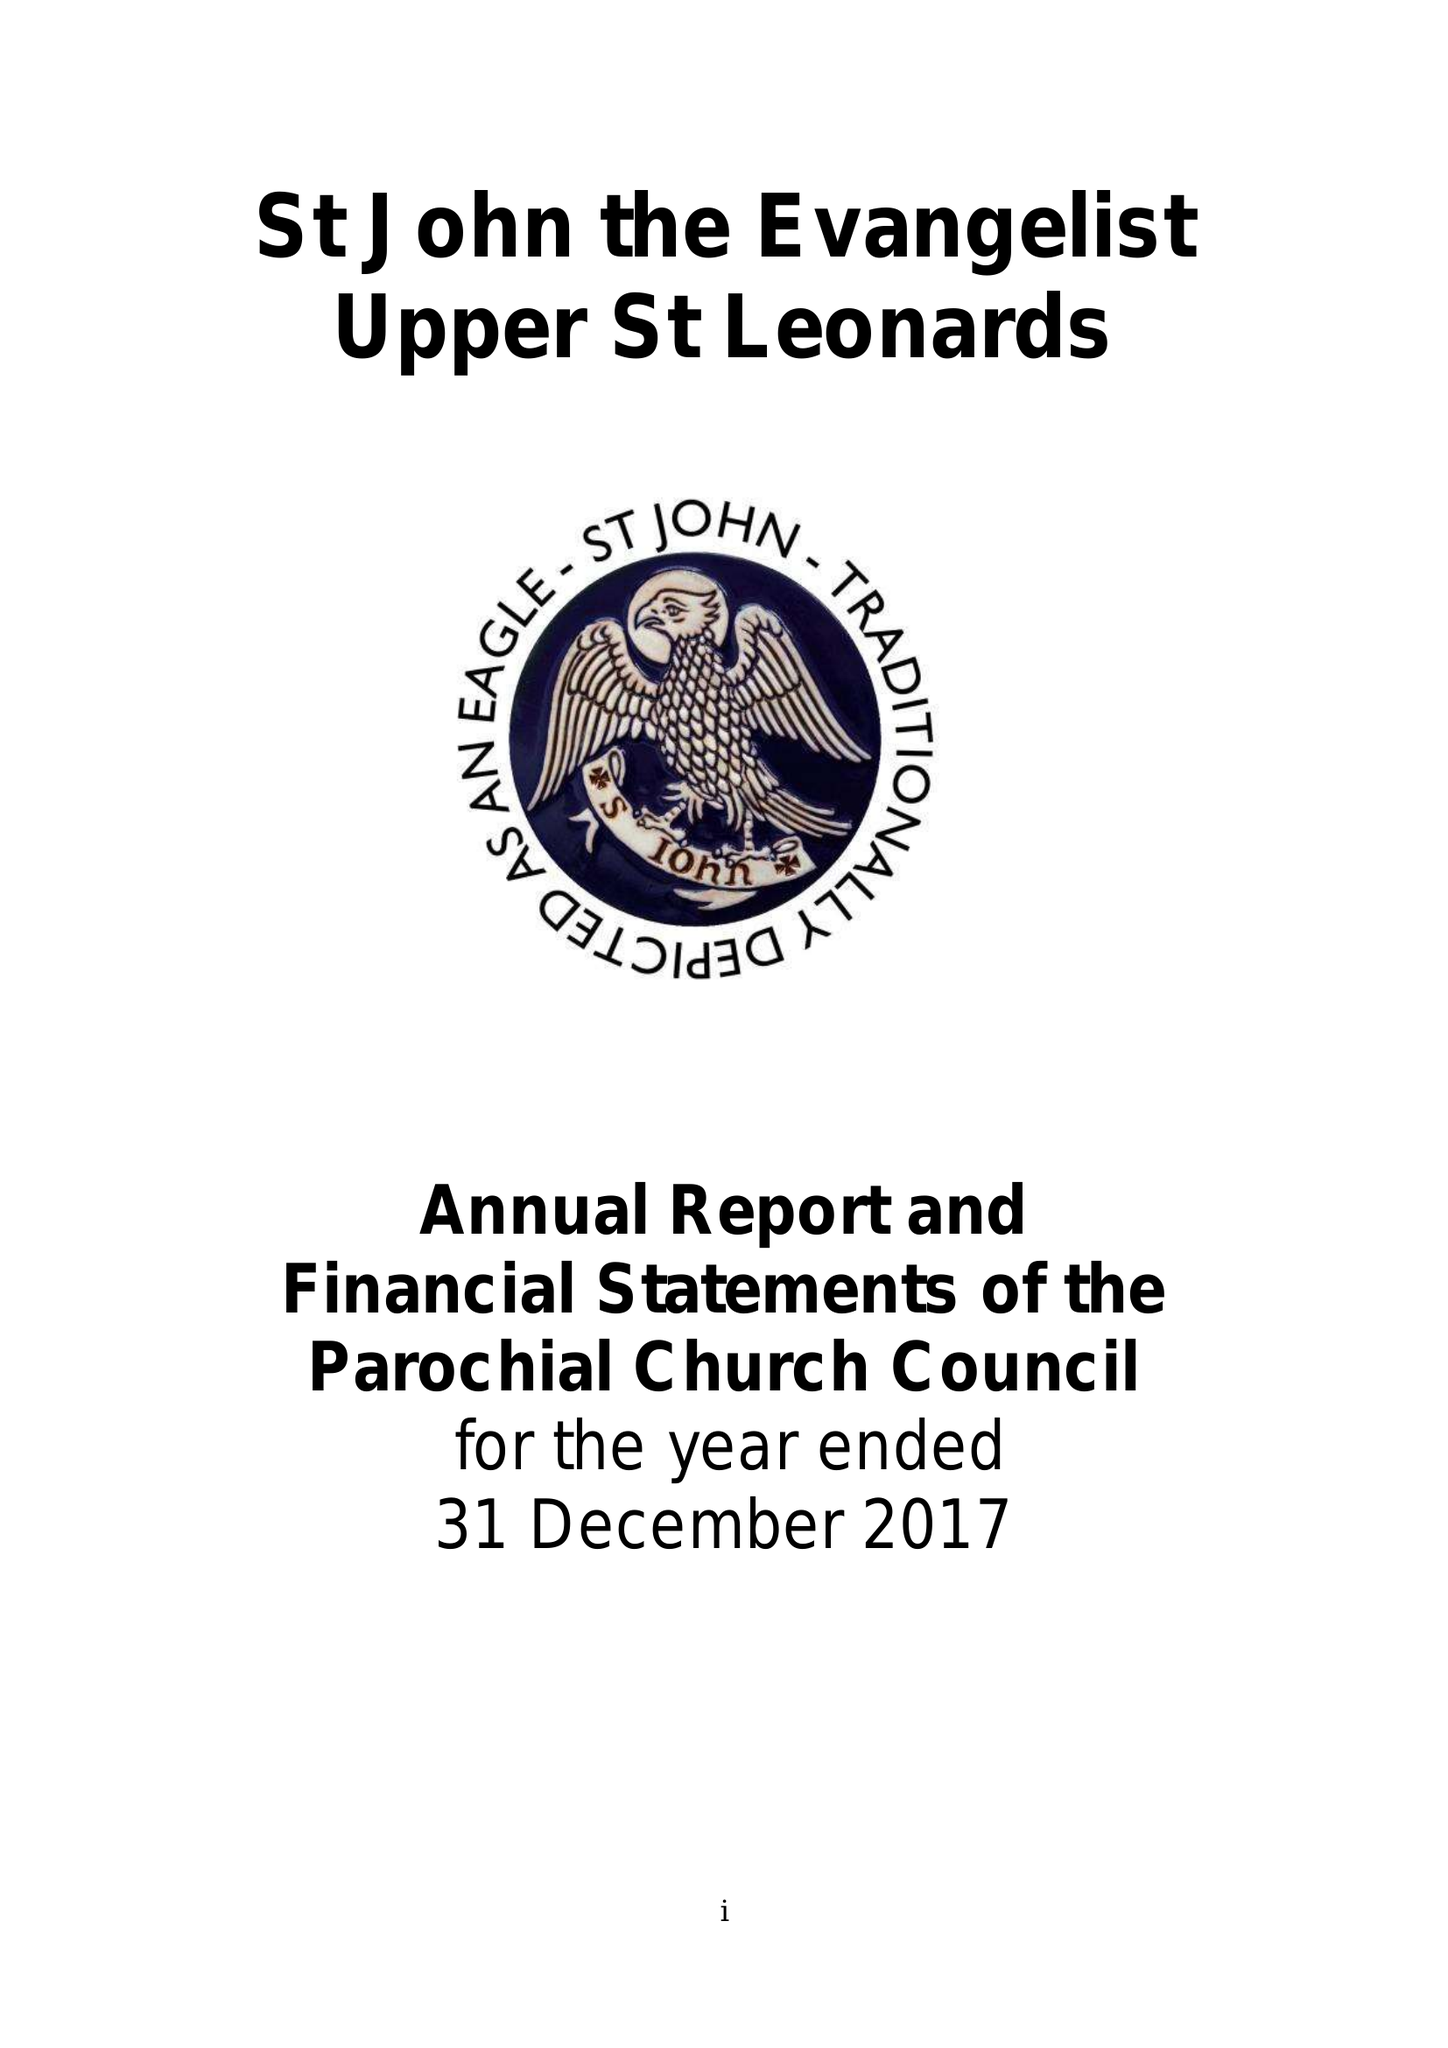What is the value for the address__street_line?
Answer the question using a single word or phrase. PEVENSEY ROAD 